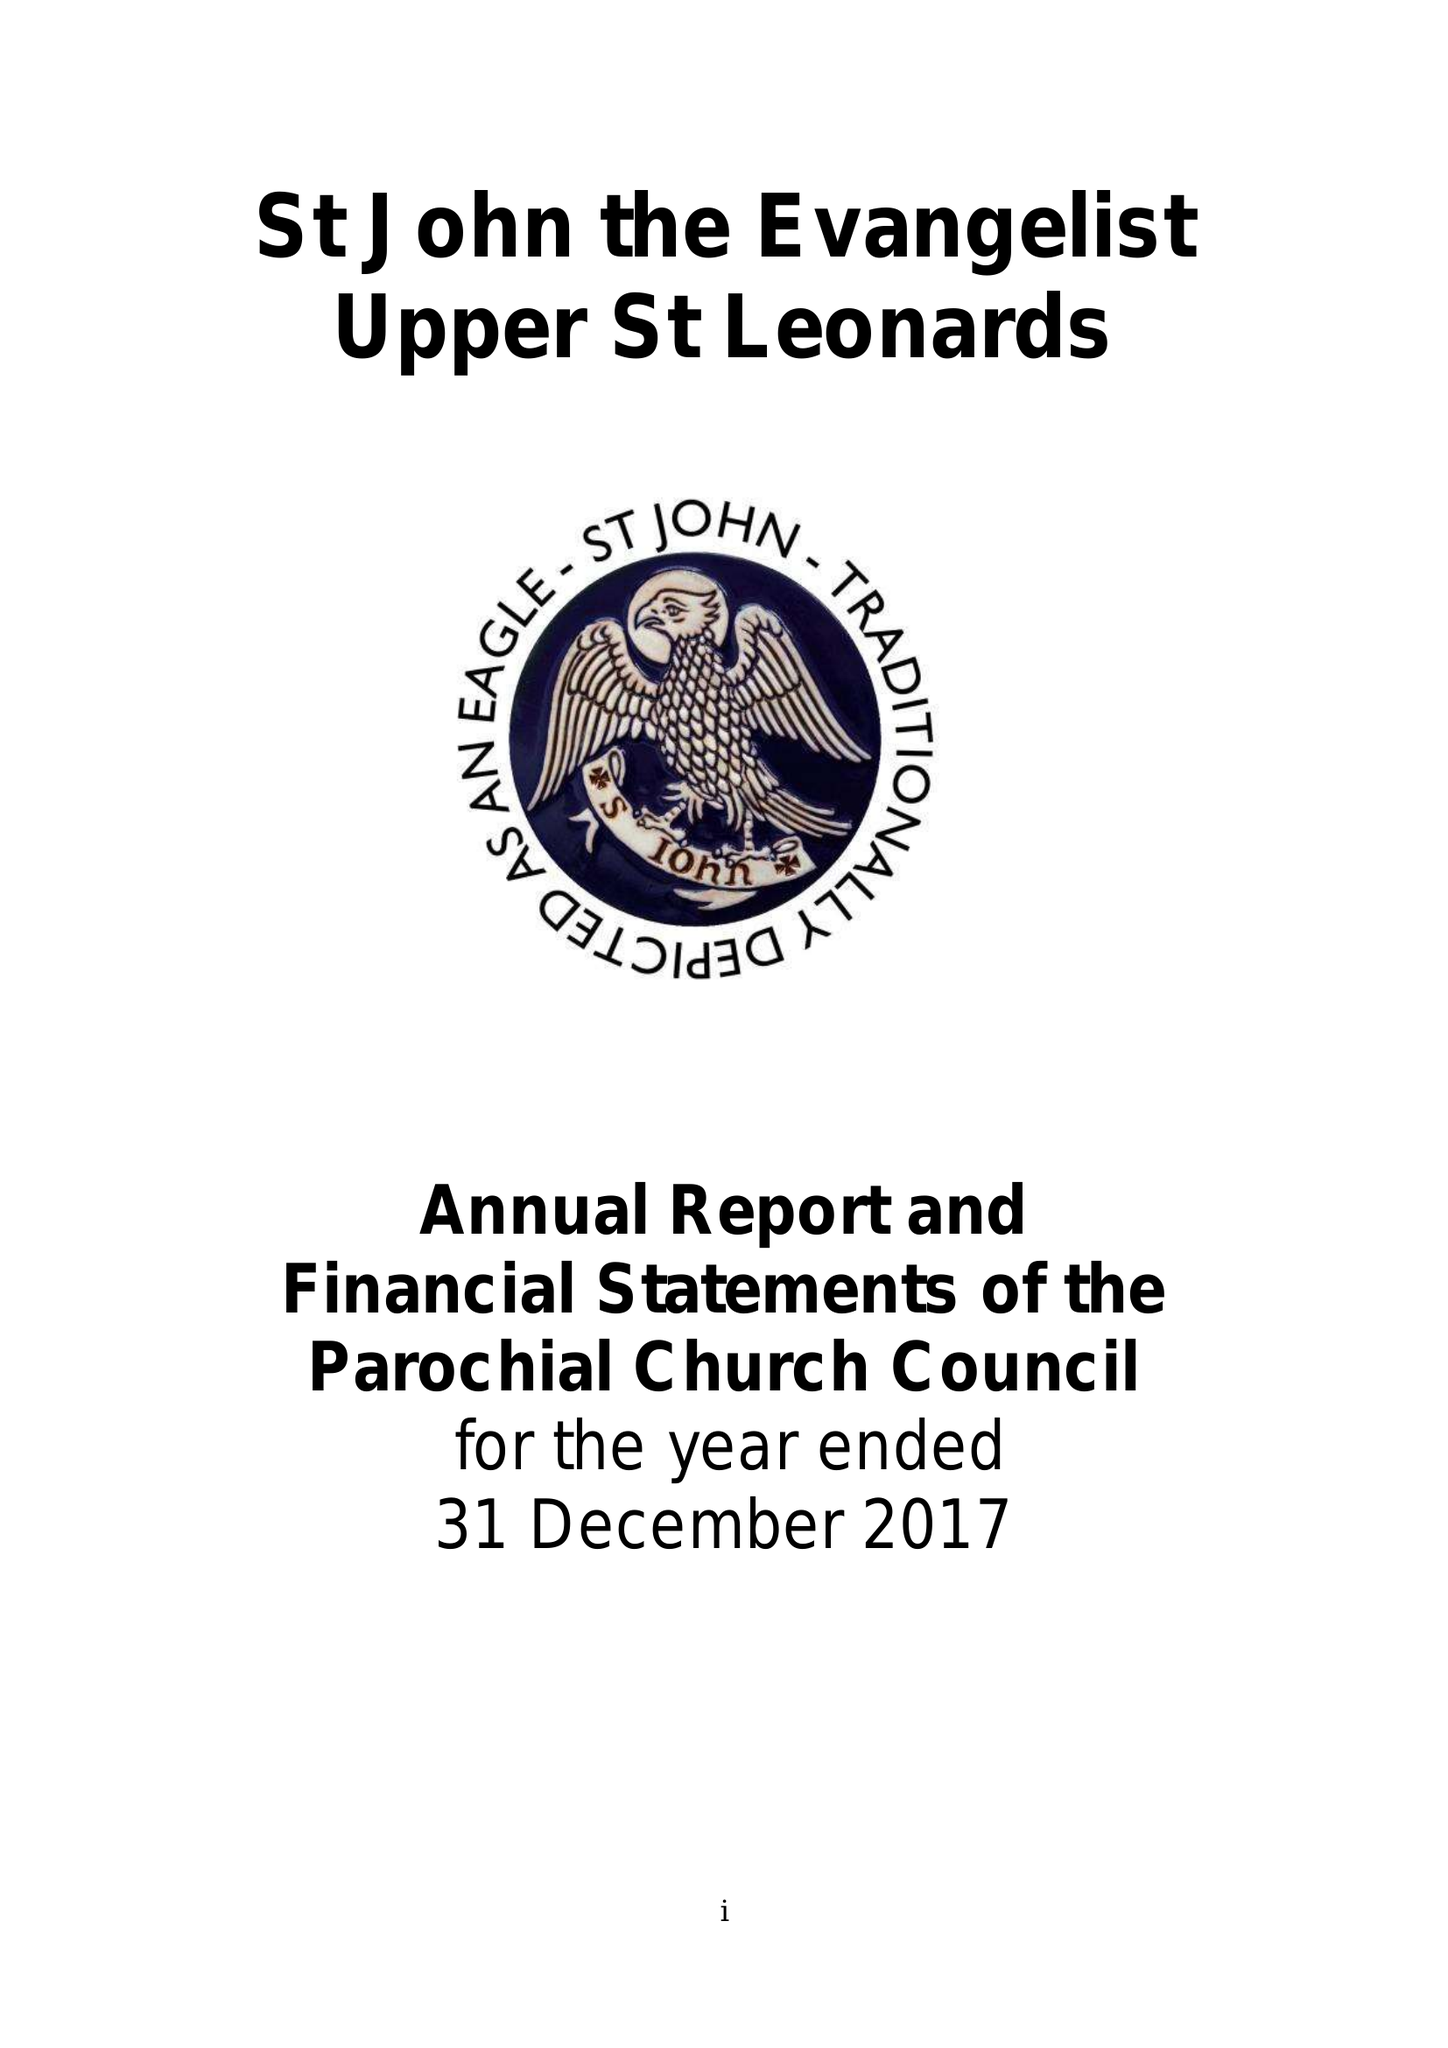What is the value for the address__street_line?
Answer the question using a single word or phrase. PEVENSEY ROAD 